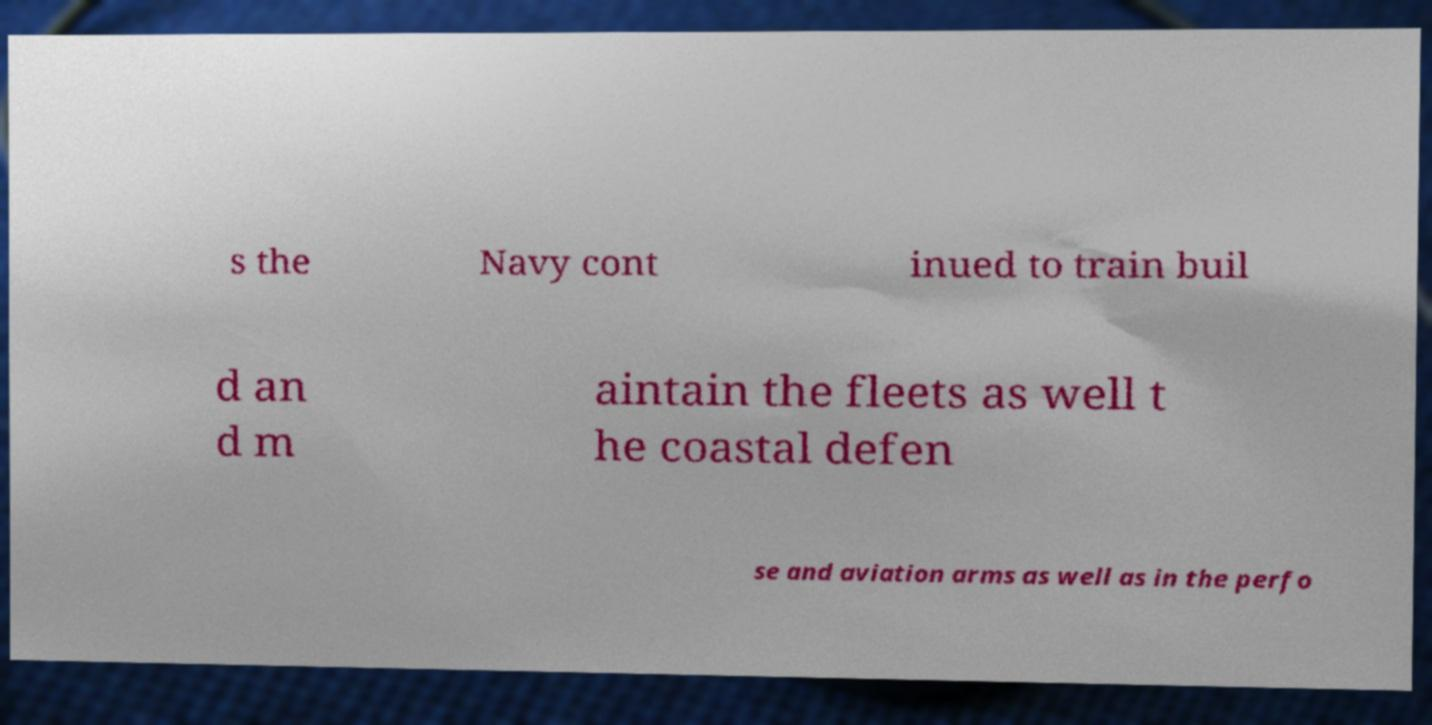Please identify and transcribe the text found in this image. s the Navy cont inued to train buil d an d m aintain the fleets as well t he coastal defen se and aviation arms as well as in the perfo 